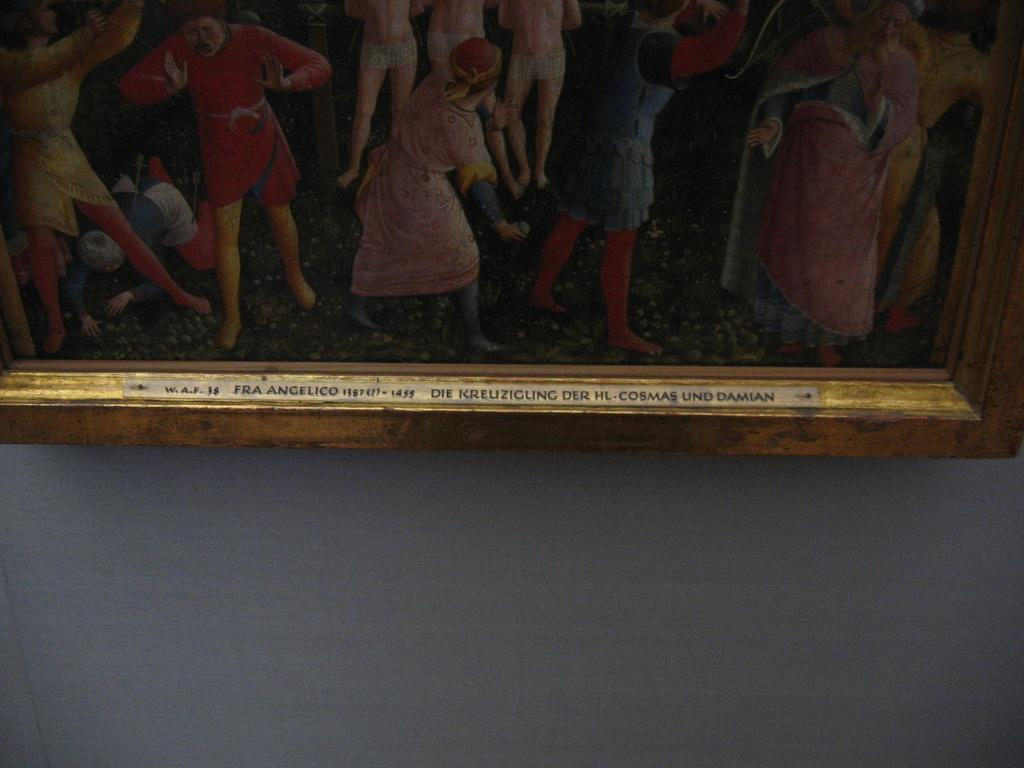What is on the wall in the image? There is a frame on the wall in the image. What is inside the frame? The frame contains pictures of people. What type of breakfast is being served in the image? There is no breakfast visible in the image; it only features a frame with pictures of people on a wall. 